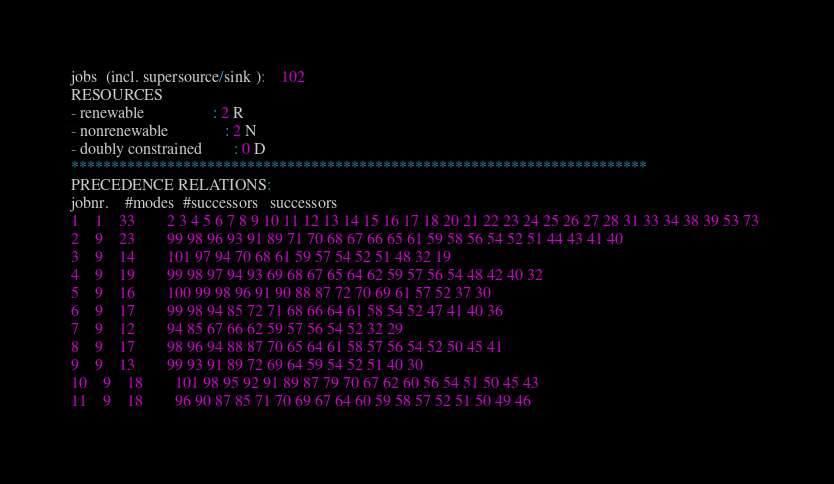<code> <loc_0><loc_0><loc_500><loc_500><_ObjectiveC_>jobs  (incl. supersource/sink ):	102
RESOURCES
- renewable                 : 2 R
- nonrenewable              : 2 N
- doubly constrained        : 0 D
************************************************************************
PRECEDENCE RELATIONS:
jobnr.    #modes  #successors   successors
1	1	33		2 3 4 5 6 7 8 9 10 11 12 13 14 15 16 17 18 20 21 22 23 24 25 26 27 28 31 33 34 38 39 53 73 
2	9	23		99 98 96 93 91 89 71 70 68 67 66 65 61 59 58 56 54 52 51 44 43 41 40 
3	9	14		101 97 94 70 68 61 59 57 54 52 51 48 32 19 
4	9	19		99 98 97 94 93 69 68 67 65 64 62 59 57 56 54 48 42 40 32 
5	9	16		100 99 98 96 91 90 88 87 72 70 69 61 57 52 37 30 
6	9	17		99 98 94 85 72 71 68 66 64 61 58 54 52 47 41 40 36 
7	9	12		94 85 67 66 62 59 57 56 54 52 32 29 
8	9	17		98 96 94 88 87 70 65 64 61 58 57 56 54 52 50 45 41 
9	9	13		99 93 91 89 72 69 64 59 54 52 51 40 30 
10	9	18		101 98 95 92 91 89 87 79 70 67 62 60 56 54 51 50 45 43 
11	9	18		96 90 87 85 71 70 69 67 64 60 59 58 57 52 51 50 49 46 </code> 